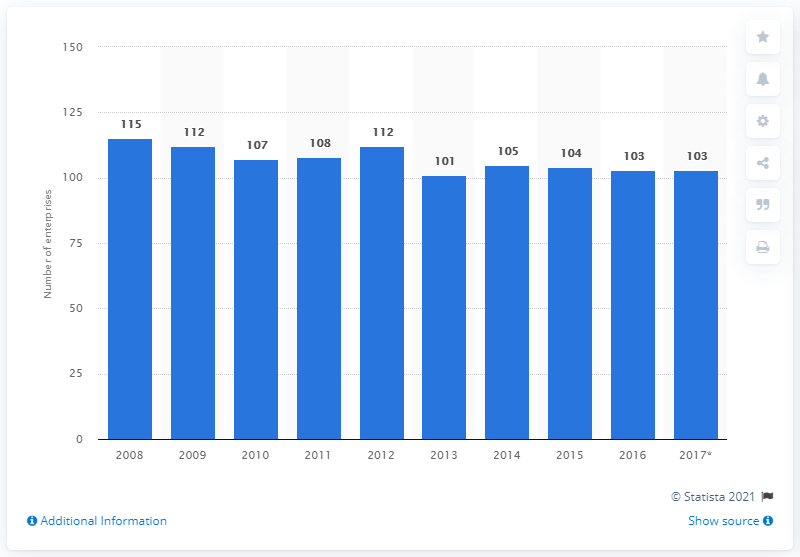Point out several critical features in this image. In 2016, there were 103 enterprises in Norway that manufactured glass and glass products. 